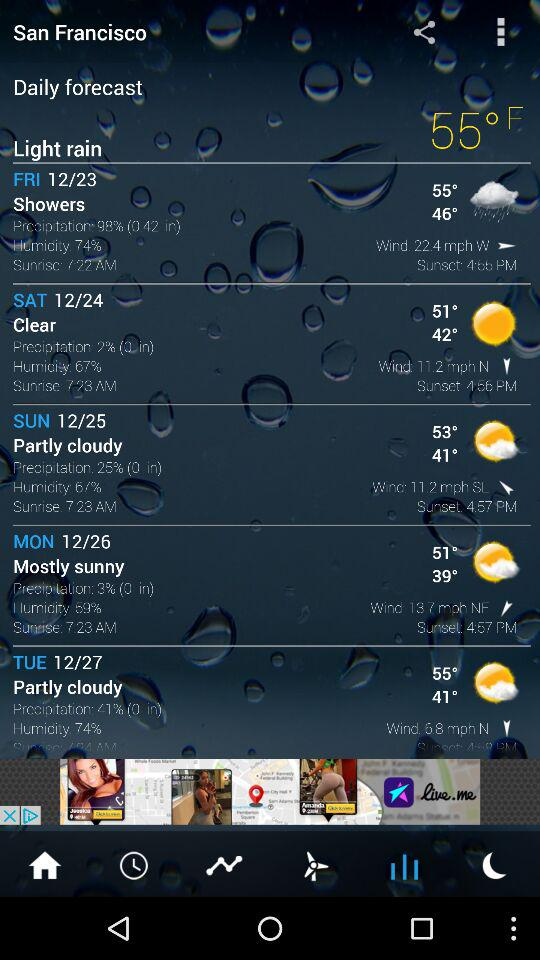What is the location? The location is San Francisco. 